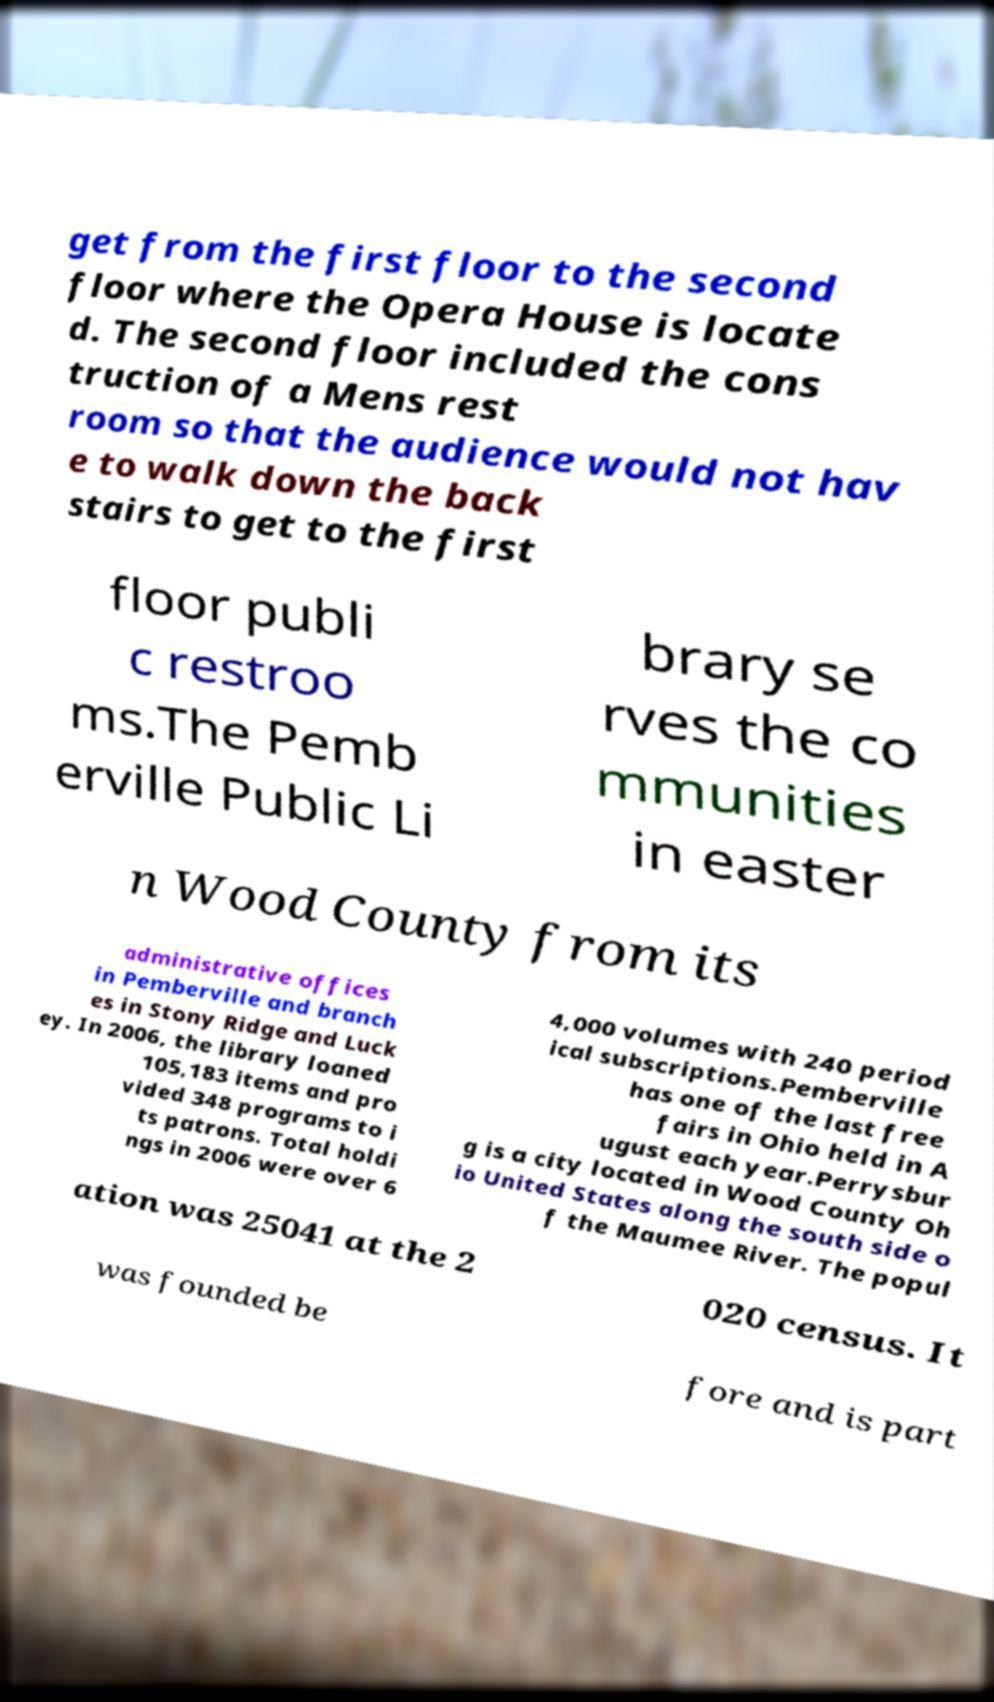What messages or text are displayed in this image? I need them in a readable, typed format. get from the first floor to the second floor where the Opera House is locate d. The second floor included the cons truction of a Mens rest room so that the audience would not hav e to walk down the back stairs to get to the first floor publi c restroo ms.The Pemb erville Public Li brary se rves the co mmunities in easter n Wood County from its administrative offices in Pemberville and branch es in Stony Ridge and Luck ey. In 2006, the library loaned 105,183 items and pro vided 348 programs to i ts patrons. Total holdi ngs in 2006 were over 6 4,000 volumes with 240 period ical subscriptions.Pemberville has one of the last free fairs in Ohio held in A ugust each year.Perrysbur g is a city located in Wood County Oh io United States along the south side o f the Maumee River. The popul ation was 25041 at the 2 020 census. It was founded be fore and is part 